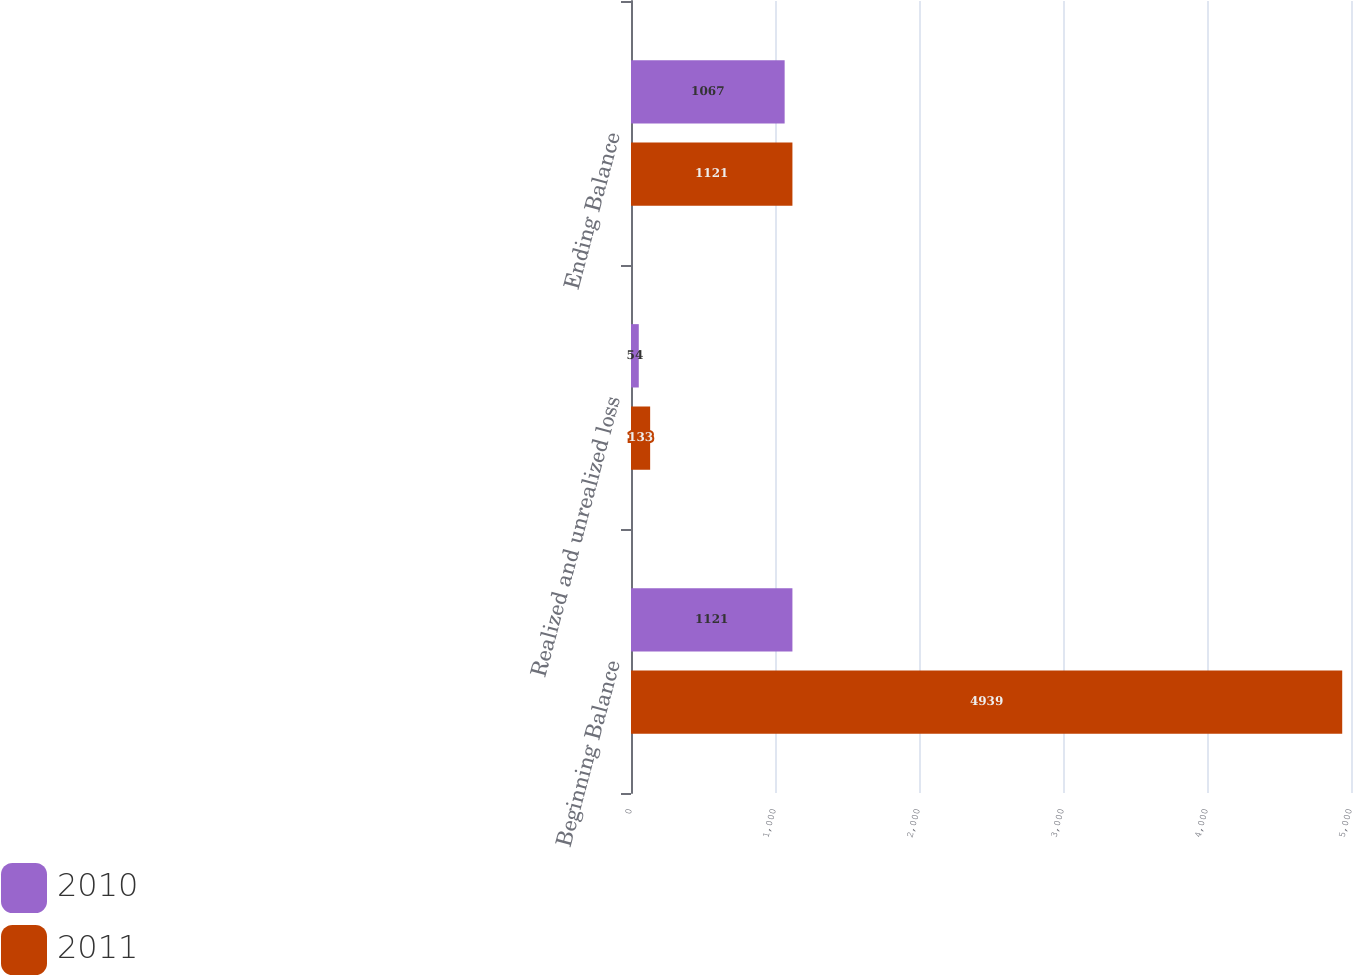Convert chart. <chart><loc_0><loc_0><loc_500><loc_500><stacked_bar_chart><ecel><fcel>Beginning Balance<fcel>Realized and unrealized loss<fcel>Ending Balance<nl><fcel>2010<fcel>1121<fcel>54<fcel>1067<nl><fcel>2011<fcel>4939<fcel>133<fcel>1121<nl></chart> 